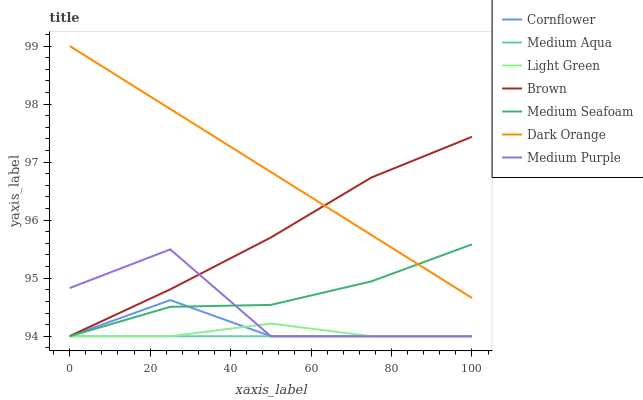Does Brown have the minimum area under the curve?
Answer yes or no. No. Does Brown have the maximum area under the curve?
Answer yes or no. No. Is Brown the smoothest?
Answer yes or no. No. Is Brown the roughest?
Answer yes or no. No. Does Brown have the lowest value?
Answer yes or no. No. Does Brown have the highest value?
Answer yes or no. No. Is Medium Aqua less than Dark Orange?
Answer yes or no. Yes. Is Dark Orange greater than Medium Aqua?
Answer yes or no. Yes. Does Medium Aqua intersect Dark Orange?
Answer yes or no. No. 